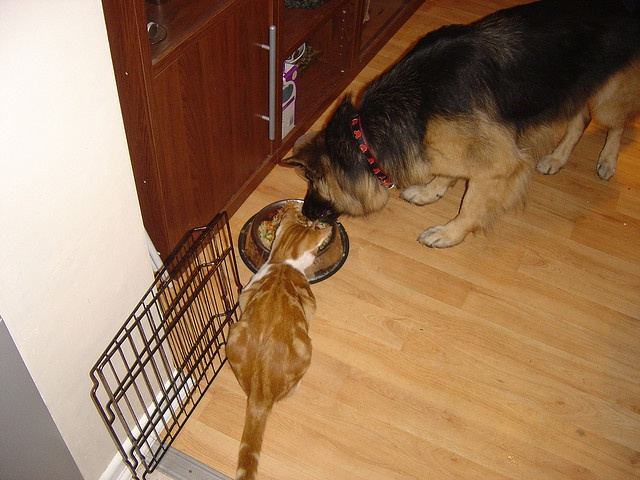Describe the objects in this image and their specific colors. I can see dog in lightgray, black, maroon, and gray tones, cat in lightgray, olive, tan, and maroon tones, bowl in lightgray, black, maroon, and brown tones, and bowl in lightgray, maroon, olive, and black tones in this image. 